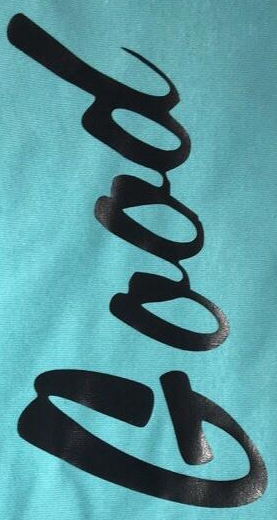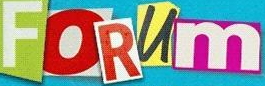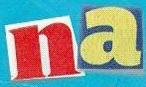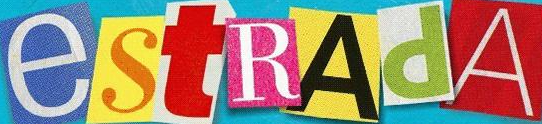Read the text from these images in sequence, separated by a semicolon. Good; FORUm; na; estRAdA 